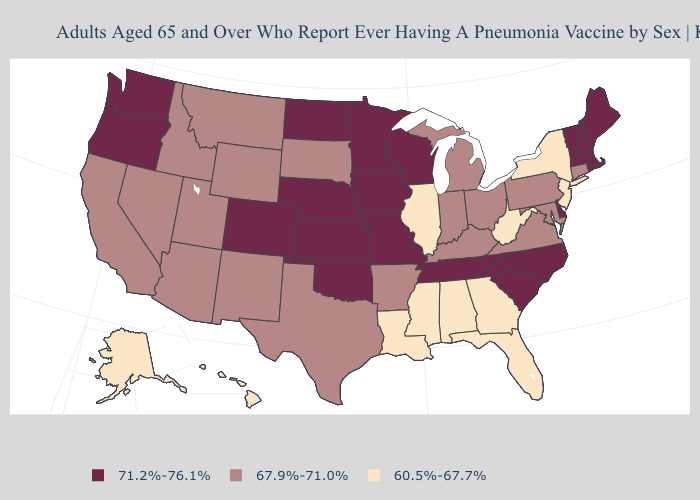Does the first symbol in the legend represent the smallest category?
Concise answer only. No. Name the states that have a value in the range 60.5%-67.7%?
Write a very short answer. Alabama, Alaska, Florida, Georgia, Hawaii, Illinois, Louisiana, Mississippi, New Jersey, New York, West Virginia. Does Idaho have a lower value than Arizona?
Concise answer only. No. Among the states that border Iowa , does Missouri have the highest value?
Give a very brief answer. Yes. Name the states that have a value in the range 60.5%-67.7%?
Keep it brief. Alabama, Alaska, Florida, Georgia, Hawaii, Illinois, Louisiana, Mississippi, New Jersey, New York, West Virginia. Among the states that border Nebraska , which have the highest value?
Concise answer only. Colorado, Iowa, Kansas, Missouri. What is the value of Pennsylvania?
Be succinct. 67.9%-71.0%. Which states have the highest value in the USA?
Concise answer only. Colorado, Delaware, Iowa, Kansas, Maine, Massachusetts, Minnesota, Missouri, Nebraska, New Hampshire, North Carolina, North Dakota, Oklahoma, Oregon, Rhode Island, South Carolina, Tennessee, Vermont, Washington, Wisconsin. What is the lowest value in states that border Tennessee?
Write a very short answer. 60.5%-67.7%. Which states hav the highest value in the West?
Concise answer only. Colorado, Oregon, Washington. Which states have the highest value in the USA?
Concise answer only. Colorado, Delaware, Iowa, Kansas, Maine, Massachusetts, Minnesota, Missouri, Nebraska, New Hampshire, North Carolina, North Dakota, Oklahoma, Oregon, Rhode Island, South Carolina, Tennessee, Vermont, Washington, Wisconsin. Among the states that border Georgia , which have the lowest value?
Short answer required. Alabama, Florida. Name the states that have a value in the range 67.9%-71.0%?
Give a very brief answer. Arizona, Arkansas, California, Connecticut, Idaho, Indiana, Kentucky, Maryland, Michigan, Montana, Nevada, New Mexico, Ohio, Pennsylvania, South Dakota, Texas, Utah, Virginia, Wyoming. Name the states that have a value in the range 60.5%-67.7%?
Give a very brief answer. Alabama, Alaska, Florida, Georgia, Hawaii, Illinois, Louisiana, Mississippi, New Jersey, New York, West Virginia. Which states have the lowest value in the West?
Give a very brief answer. Alaska, Hawaii. 